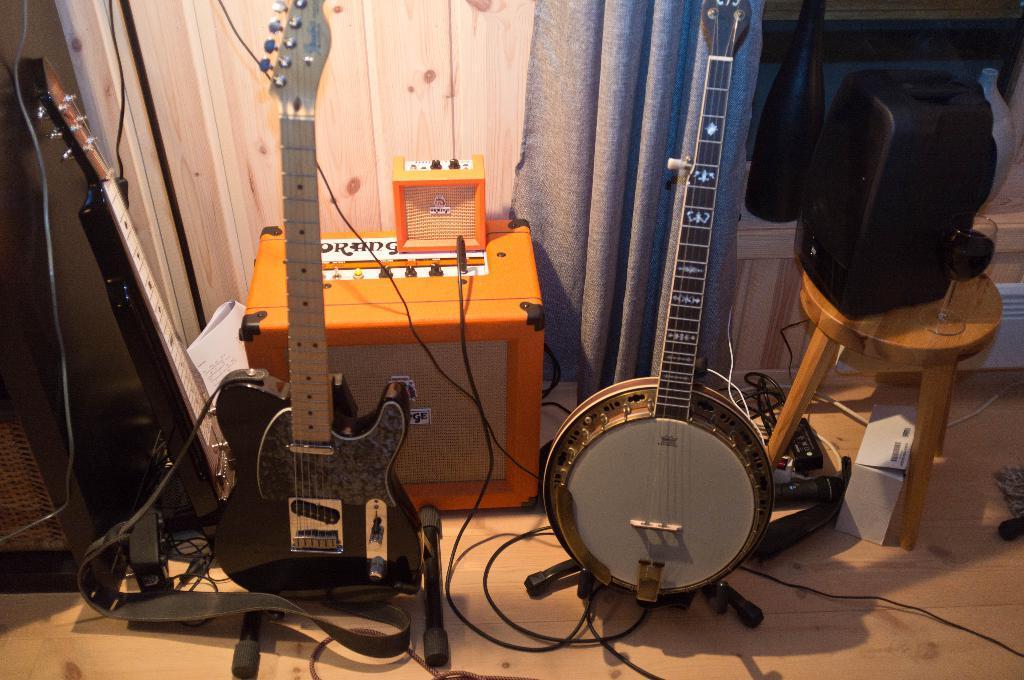Please provide a concise description of this image. We can guitars,cable,musical instruments. On the background we can see curtain. This is table. On the table we can see speaker,glass. This is floor. 